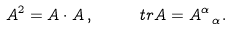<formula> <loc_0><loc_0><loc_500><loc_500>A ^ { 2 } = A \cdot A \, , \quad \ t r A = A ^ { \alpha } _ { \ \alpha } .</formula> 